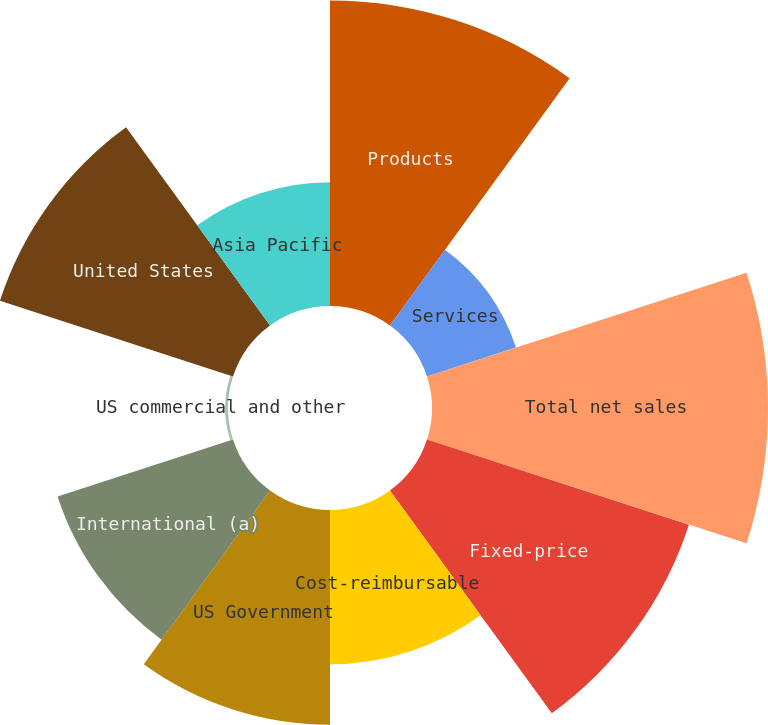Convert chart. <chart><loc_0><loc_0><loc_500><loc_500><pie_chart><fcel>Products<fcel>Services<fcel>Total net sales<fcel>Fixed-price<fcel>Cost-reimbursable<fcel>US Government<fcel>International (a)<fcel>US commercial and other<fcel>United States<fcel>Asia Pacific<nl><fcel>15.79%<fcel>4.83%<fcel>17.36%<fcel>14.23%<fcel>7.97%<fcel>11.1%<fcel>9.53%<fcel>0.14%<fcel>12.66%<fcel>6.4%<nl></chart> 